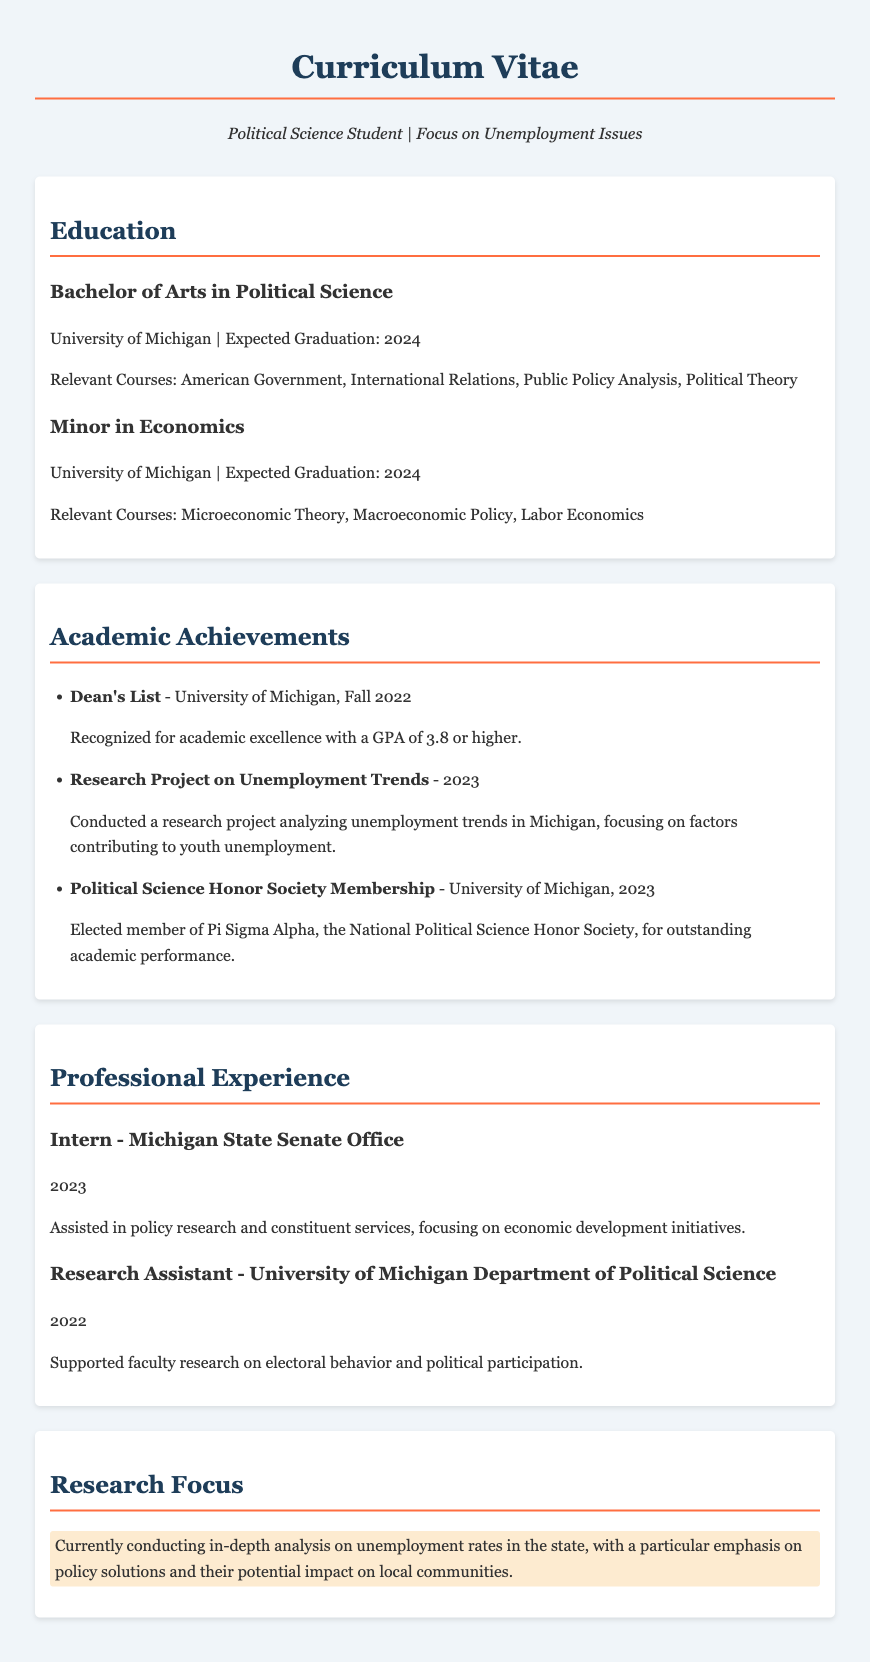What is the expected graduation year for the bachelor's degree? The expected graduation year for the bachelor's degree is mentioned in the document as 2024.
Answer: 2024 Which university is the student attending? The student is attending the University of Michigan, which is specified in the education section of the document.
Answer: University of Michigan What was the student's GPA to make the Dean's List? The document states that the GPA required to make the Dean's List is 3.8 or higher.
Answer: 3.8 or higher What is the student's minor field of study? The document lists a Minor in Economics under the Education section, indicating the student's secondary field of study.
Answer: Economics What year did the student conduct a research project on unemployment trends? The research project on unemployment trends was conducted in the year 2023, as indicated in the academic achievements.
Answer: 2023 What is the name of the honor society the student is a member of? The student is a member of Pi Sigma Alpha, which is specified in the academic achievements section of the document.
Answer: Pi Sigma Alpha What type of internship did the student hold in 2023? The document states that the student held an internship at the Michigan State Senate Office, which identifies the type of position held in 2023.
Answer: Intern - Michigan State Senate Office What is the current research focus of the student? The document outlines that the current research focus is on unemployment rates, specifically analyzing policy solutions and their impact on local communities.
Answer: Unemployment rates and policy solutions How many relevant courses are listed under the Bachelor of Arts in Political Science? The document lists four relevant courses under the Bachelor of Arts in Political Science.
Answer: Four 